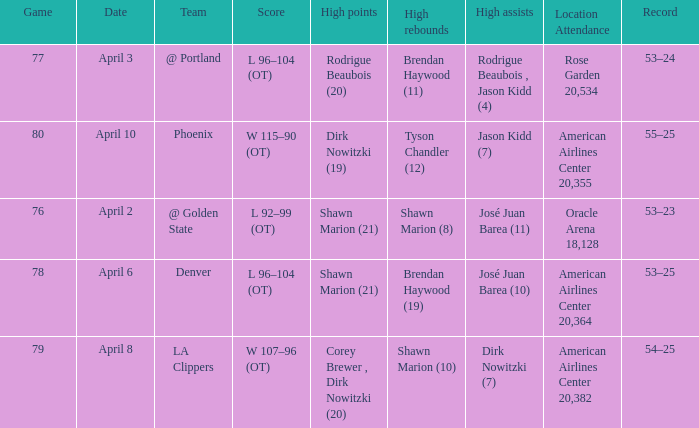Can you give me this table as a dict? {'header': ['Game', 'Date', 'Team', 'Score', 'High points', 'High rebounds', 'High assists', 'Location Attendance', 'Record'], 'rows': [['77', 'April 3', '@ Portland', 'L 96–104 (OT)', 'Rodrigue Beaubois (20)', 'Brendan Haywood (11)', 'Rodrigue Beaubois , Jason Kidd (4)', 'Rose Garden 20,534', '53–24'], ['80', 'April 10', 'Phoenix', 'W 115–90 (OT)', 'Dirk Nowitzki (19)', 'Tyson Chandler (12)', 'Jason Kidd (7)', 'American Airlines Center 20,355', '55–25'], ['76', 'April 2', '@ Golden State', 'L 92–99 (OT)', 'Shawn Marion (21)', 'Shawn Marion (8)', 'José Juan Barea (11)', 'Oracle Arena 18,128', '53–23'], ['78', 'April 6', 'Denver', 'L 96–104 (OT)', 'Shawn Marion (21)', 'Brendan Haywood (19)', 'José Juan Barea (10)', 'American Airlines Center 20,364', '53–25'], ['79', 'April 8', 'LA Clippers', 'W 107–96 (OT)', 'Corey Brewer , Dirk Nowitzki (20)', 'Shawn Marion (10)', 'Dirk Nowitzki (7)', 'American Airlines Center 20,382', '54–25']]} What is the record after the Phoenix game? 55–25. 